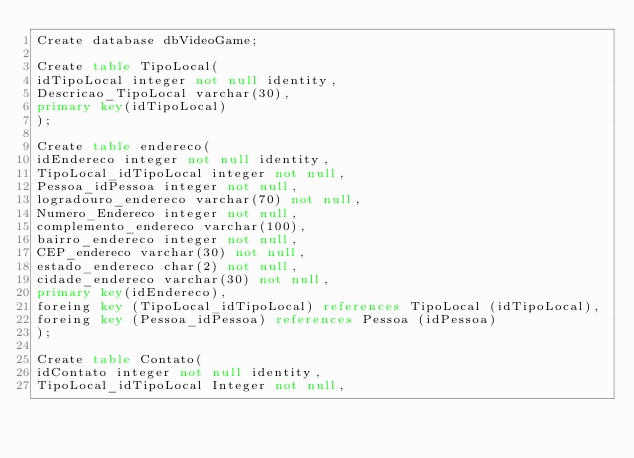<code> <loc_0><loc_0><loc_500><loc_500><_SQL_>Create database dbVideoGame;

Create table TipoLocal(
idTipoLocal integer not null identity,
Descricao_TipoLocal varchar(30),
primary key(idTipoLocal)
);

Create table endereco(
idEndereco integer not null identity,
TipoLocal_idTipoLocal integer not null,
Pessoa_idPessoa integer not null,
logradouro_endereco varchar(70) not null,
Numero_Endereco integer not null,
complemento_endereco varchar(100),
bairro_endereco integer not null,
CEP_endereco varchar(30) not null,
estado_endereco char(2) not null,
cidade_endereco varchar(30) not null,
primary key(idEndereco),
foreing key (TipoLocal_idTipoLocal) references TipoLocal (idTipoLocal),
foreing key (Pessoa_idPessoa) references Pessoa (idPessoa) 
);

Create table Contato(
idContato integer not null identity,
TipoLocal_idTipoLocal Integer not null,</code> 